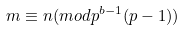Convert formula to latex. <formula><loc_0><loc_0><loc_500><loc_500>m \equiv n ( m o d p ^ { b - 1 } ( p - 1 ) )</formula> 